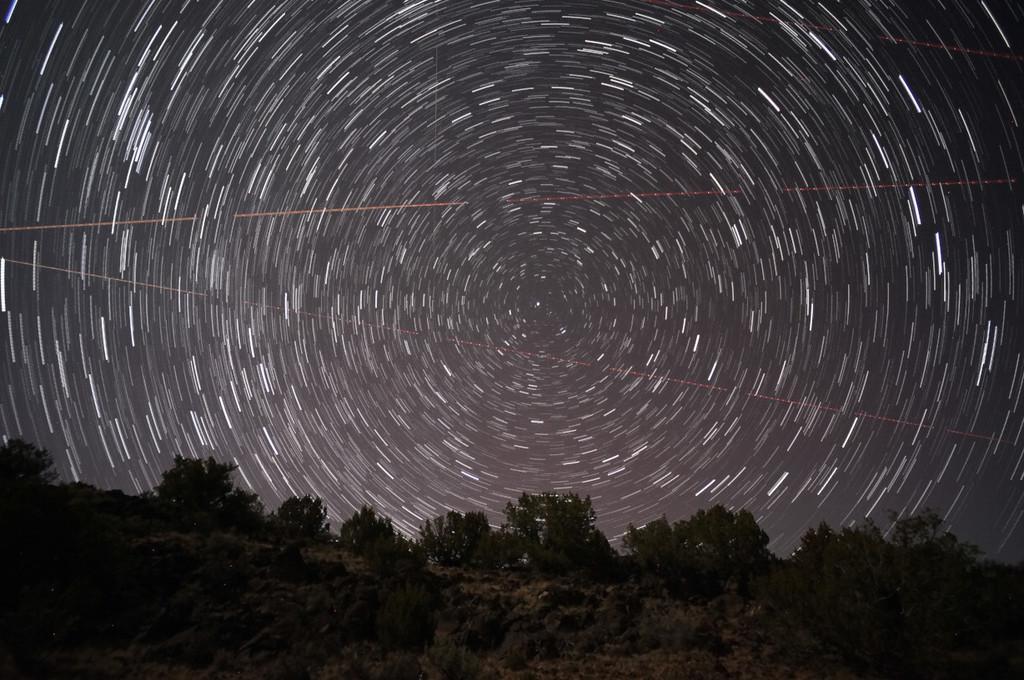How would you summarize this image in a sentence or two? In this image, we can see the sky. There is a hill at the bottom of the image contains some plants. 